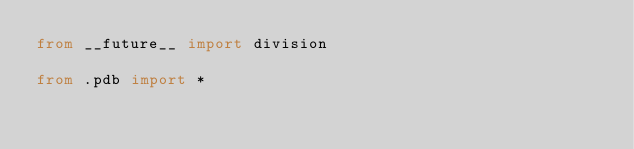Convert code to text. <code><loc_0><loc_0><loc_500><loc_500><_Python_>from __future__ import division

from .pdb import *
</code> 